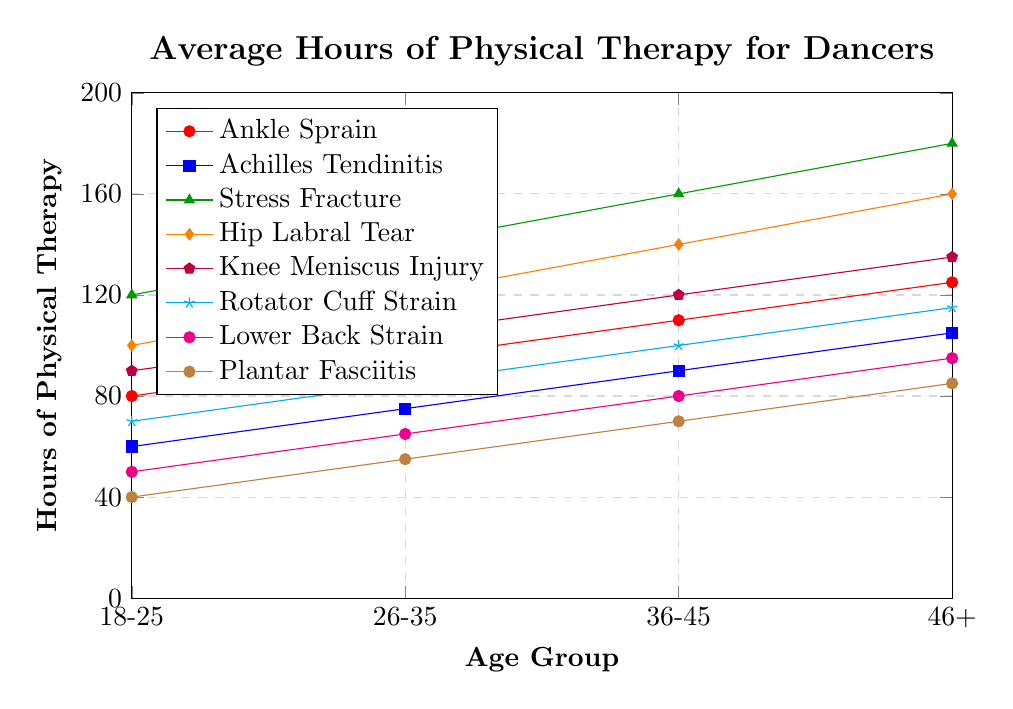What is the average number of hours of physical therapy required for an ankle sprain in all age groups? The values for ankle sprain in the age groups 18-25, 26-35, 36-45, and 46+ are 80, 95, 110, and 125 hours, respectively. Adding these values gives 80 + 95 + 110 + 125 = 410. Dividing this sum by 4 (the number of age groups) yields an average of 410 / 4 = 102.5.
Answer: 102.5 How much more physical therapy is needed for a stress fracture compared to a plantar fasciitis in the 36-45 age group? For the 36-45 age group, the hours required for a stress fracture are 160, and for plantar fasciitis, it is 70. The difference can be found by subtracting the smaller value from the larger value: 160 - 70 = 90.
Answer: 90 Between which two injury types is there the largest increase in therapy hours from the 18-25 age group to the 46+ age group? To find the largest increase, we need to calculate the difference for each injury type from the 18-25 age group to the 46+ age group: 
- Ankle Sprain: 125 - 80 = 45 
- Achilles Tendinitis: 105 - 60 = 45 
- Stress Fracture: 180 - 120 = 60 
- Hip Labral Tear: 160 - 100 = 60 
- Knee Meniscus Injury: 135 - 90 = 45 
- Rotator Cuff Strain: 115 - 70 = 45 
- Lower Back Strain: 95 - 50 = 45 
- Plantar Fasciitis: 85 - 40 = 45 
The largest increases are for Stress Fracture and Hip Labral Tear, both at 60.
Answer: Stress Fracture and Hip Labral Tear Which age group has the highest average hours of physical therapy across all injury types? To find the highest average, we will sum the hours for each age group and then average:
- 18-25: (80 + 60 + 120 + 100 + 90 + 70 + 50 + 40) / 8 = 610 / 8 = 76.25
- 26-35: (95 + 75 + 140 + 120 + 105 + 85 + 65 + 55) / 8 = 740 / 8 = 92.5
- 36-45: (110 + 90 + 160 + 140 + 120 + 100 + 80 + 70) / 8 = 870 / 8 = 108.75
- 46+: (125 + 105 + 180 + 160 + 135 + 115 + 95 + 85) / 8 = 1000 / 8 = 125
The highest average is for the 46+ age group, with an average of 125 hours.
Answer: 46+ How many more hours of physical therapy are required on average for dancers aged 26-35 compared to those aged 18-25 across all injury types? First calculate the average for 26-35 and 18-25:
- 26-35: (95 + 75 + 140 + 120 + 105 + 85 + 65 + 55) / 8 = 92.5
- 18-25: (80 + 60 + 120 + 100 + 90 + 70 + 50 + 40) / 8 = 76.25
The difference is 92.5 - 76.25 = 16.25.
Answer: 16.25 Which injury type shows the least increase in therapy hours from the 18-25 age group to the 26-35 age group? To find the least increase, we will calculate differences for each injury type:
- Ankle Sprain: 95 - 80 = 15
- Achilles Tendinitis: 75 - 60 = 15
- Stress Fracture: 140 - 120 = 20
- Hip Labral Tear: 120 - 100 = 20
- Knee Meniscus Injury: 105 - 90 = 15
- Rotator Cuff Strain: 85 - 70 = 15
- Lower Back Strain: 65 - 50 = 15
- Plantar Fasciitis: 55 - 40 = 15
Several injuries have the same least increase of 15, including Ankle Sprain, Achilles Tendinitis, Knee Meniscus Injury, Rotator Cuff Strain, Lower Back Strain, and Plantar Fasciitis.
Answer: Ankle Sprain, Achilles Tendinitis, Knee Meniscus Injury, Rotator Cuff Strain, Lower Back Strain, and Plantar Fasciitis 